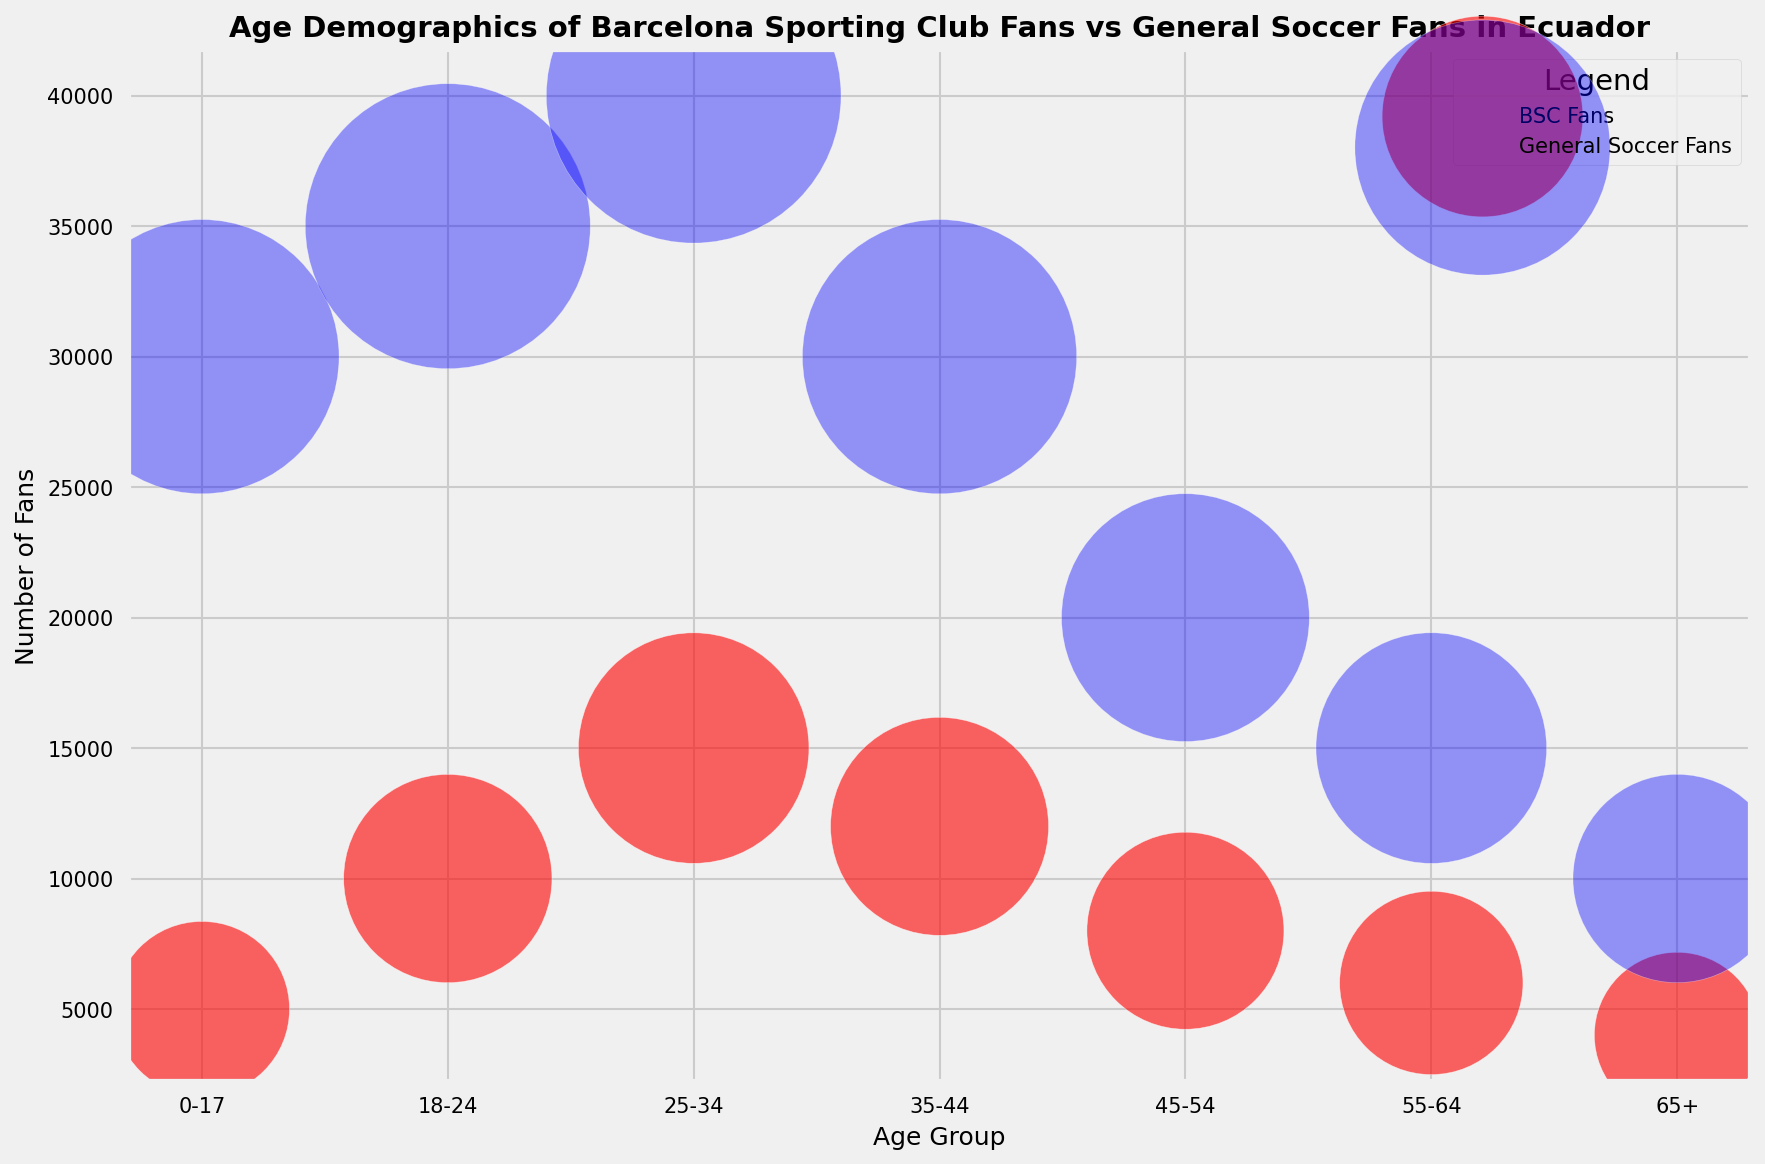What age group has the highest number of fans for both Barcelona Sporting Club and General Soccer Fans? The age group with the highest number of fans can be determined by looking at the vertical height of the bubbles for each group. The largest bubble for Barcelona Sporting Club is in the 25-34 age group with 15,000 fans. Similarly, for General Soccer Fans, the largest bubble is also in the 25-34 age group with 40,000 fans.
Answer: 25-34 Which age group has the biggest difference in the number of fans between Barcelona Sporting Club and General Soccer Fans? To find the biggest difference, subtract the number of Barcelona Sporting Club fans from the number of General Soccer Fans for each age group. The differences are: 0-17: 25,000, 18-24: 25,000, 25-34: 25,000, 35-44: 18,000, 45-54: 12,000, 55-64: 9,000, 65+: 6,000. The largest difference is 25,000, occurring in the 0-17, 18-24, and 25-34 age groups.
Answer: 0-17, 18-24, 25-34 What is the total number of Barcelona Sporting Club fans represented in the plot? Add the number of Barcelona Sporting Club fans for each age group: 5,000 + 10,000 + 15,000 + 12,000 + 8,000 + 6,000 + 4,000 = 60,000.
Answer: 60,000 Which color represents Barcelona Sporting Club fans in the plot? The visual attribute indicating the Barcelona Sporting Club fans is the red color of the bubbles. The legend in the upper right corner of the plot confirms this representation.
Answer: Red For the age group 35-44, how many more fans do Barcelona Sporting Club have compared to those aged 55-64? For the 35-44 age group, Barcelona Sporting Club has 12,000 fans. For the 55-64 age group, they have 6,000 fans. The difference is 12,000 - 6,000 = 6,000.
Answer: 6,000 Compare the size of the bubbles representing Barcelona Sporting Club fans and General Soccer Fans for the 18-24 age group. Which is larger? The size of the bubbles is proportional to the number of fans. The bubble representing General Soccer Fans for the 18-24 age group is larger since it represents 35,000 fans compared to 10,000 fans for Barcelona Sporting Club.
Answer: General Soccer Fans Do any age groups have an equal number of fans for both Barcelona Sporting Club and General Soccer Fans? To determine if any age group has an equal number of fans, compare the bubble sizes within each group. There are no age groups where the number of fans is equal for both Barcelona Sporting Club and General Soccer Fans.
Answer: No 